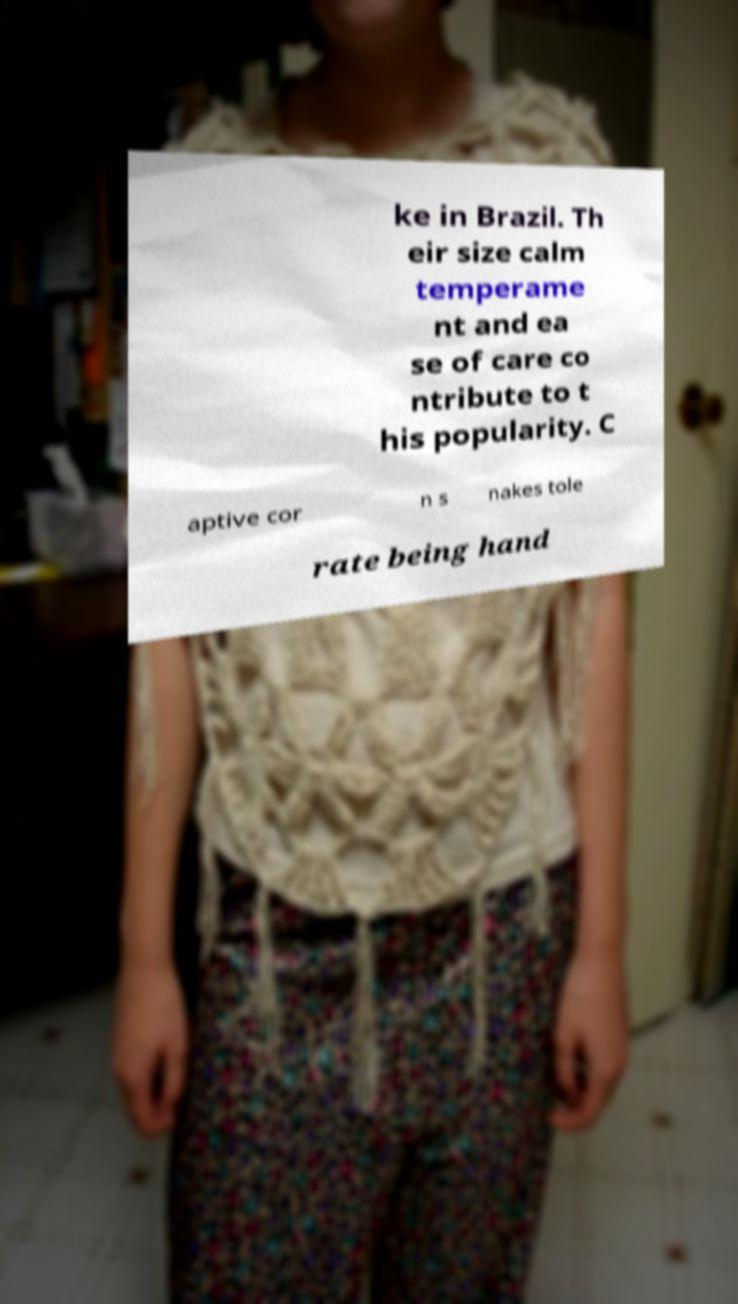What messages or text are displayed in this image? I need them in a readable, typed format. ke in Brazil. Th eir size calm temperame nt and ea se of care co ntribute to t his popularity. C aptive cor n s nakes tole rate being hand 